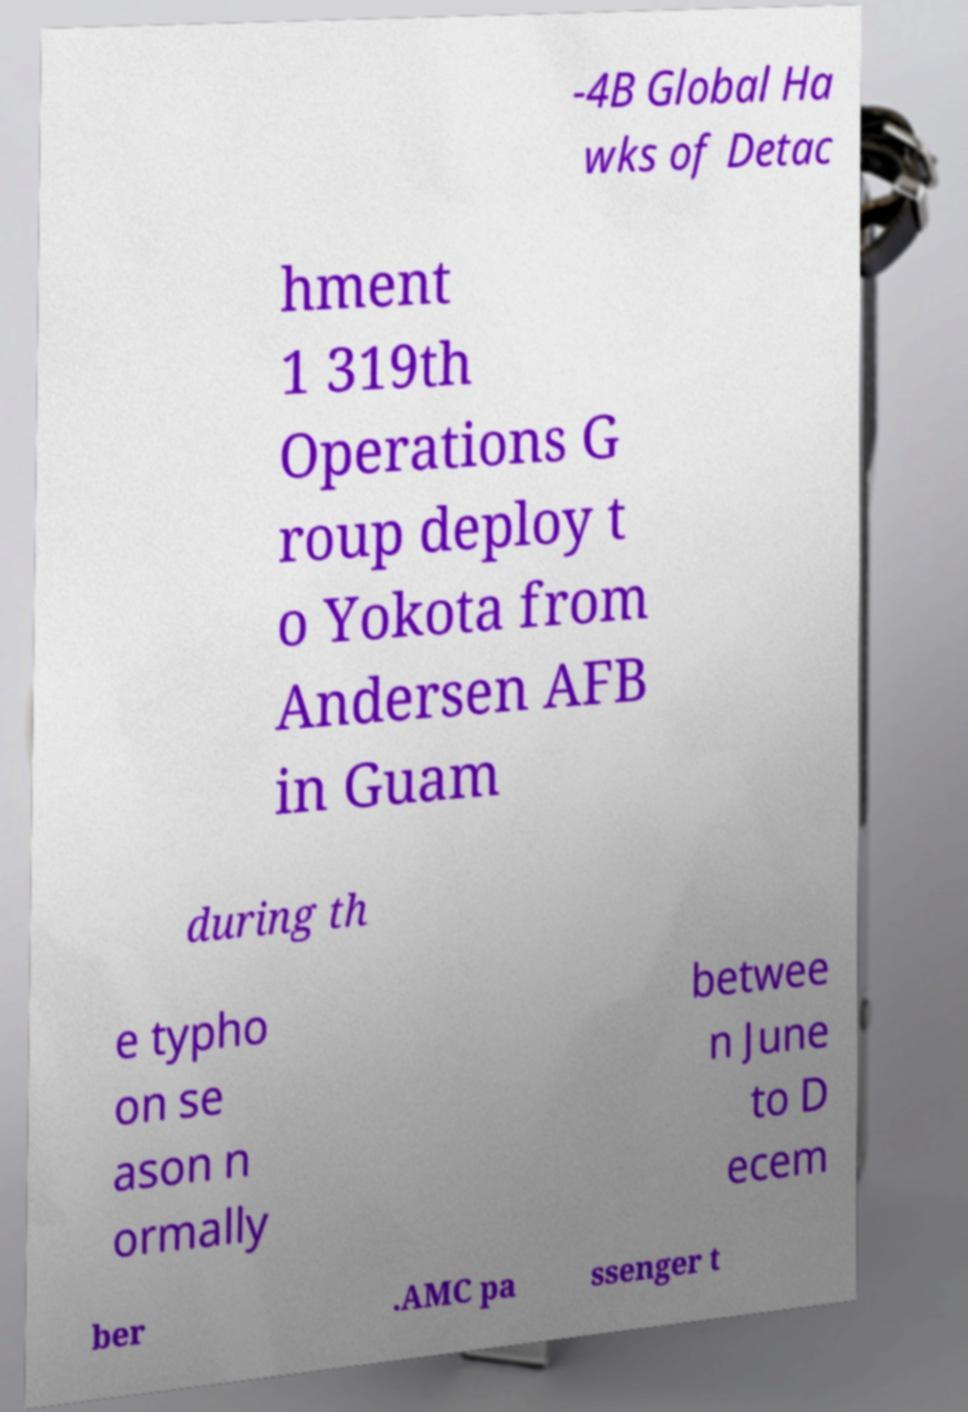There's text embedded in this image that I need extracted. Can you transcribe it verbatim? -4B Global Ha wks of Detac hment 1 319th Operations G roup deploy t o Yokota from Andersen AFB in Guam during th e typho on se ason n ormally betwee n June to D ecem ber .AMC pa ssenger t 